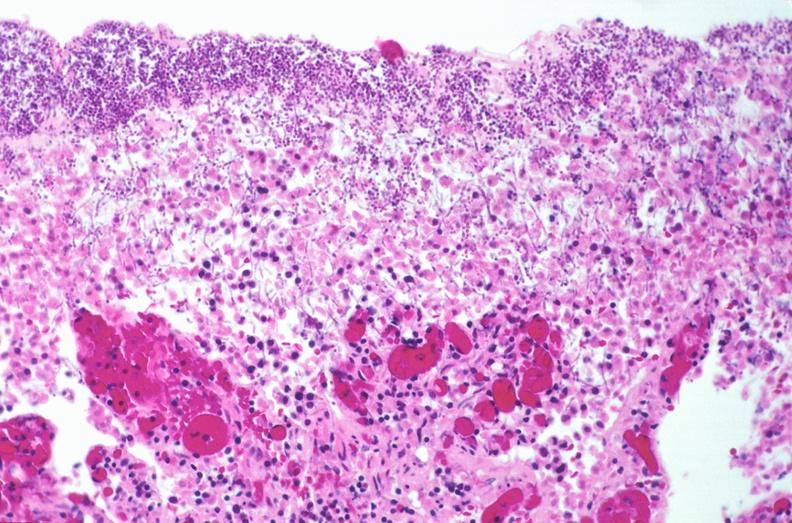s gastrointestinal present?
Answer the question using a single word or phrase. Yes 